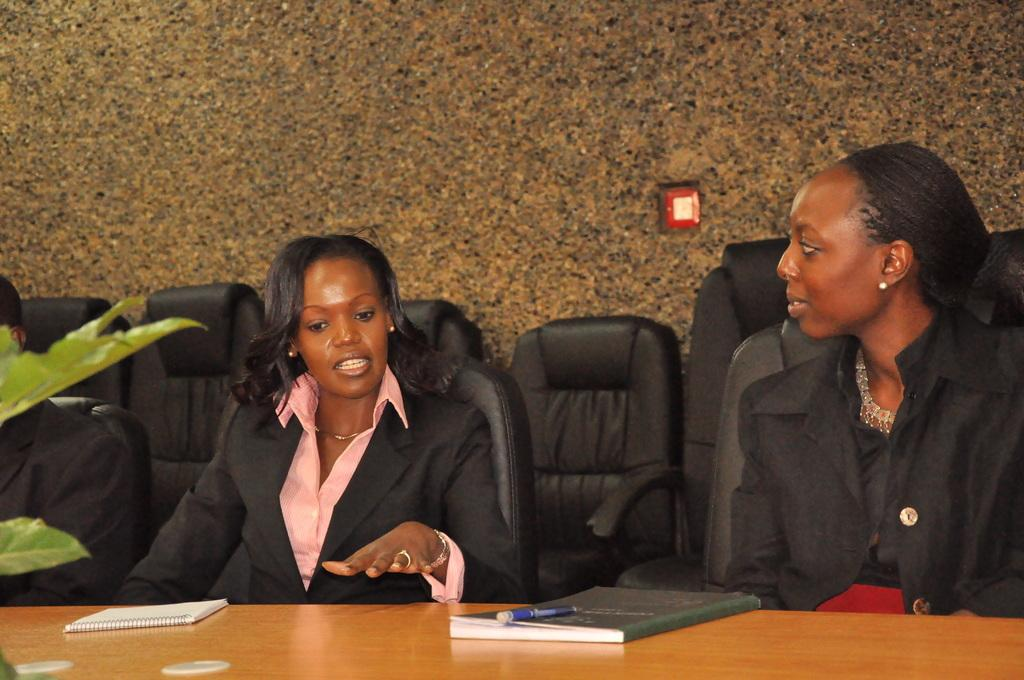What are the women doing in the image? The women are sitting on chairs in the image. Where are the chairs located in relation to the table? The chairs are near a table in the image. What items can be seen on the table? There is a book, a pen, and a plant on the table in the image. Can you describe the fight between the women and the plant in the image? There is no fight between the women and the plant in the image; the women are sitting on chairs, and the plant is on the table. 